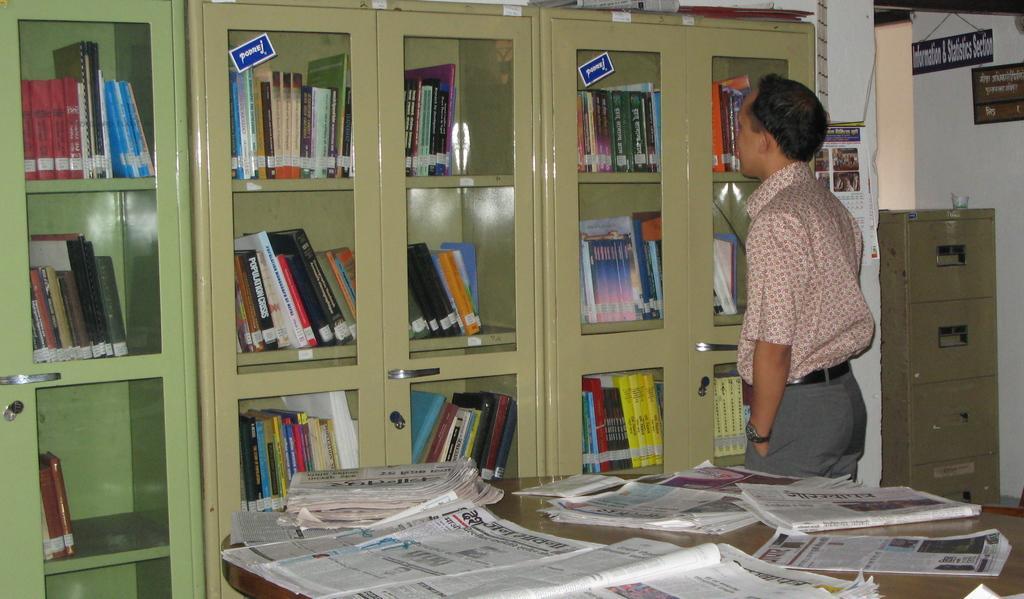Please provide a concise description of this image. There is a man standing,beside this man we can see papers on the table. Left side of the image we can see books in cupboards. In the background we can see boards on a wall and furniture. 